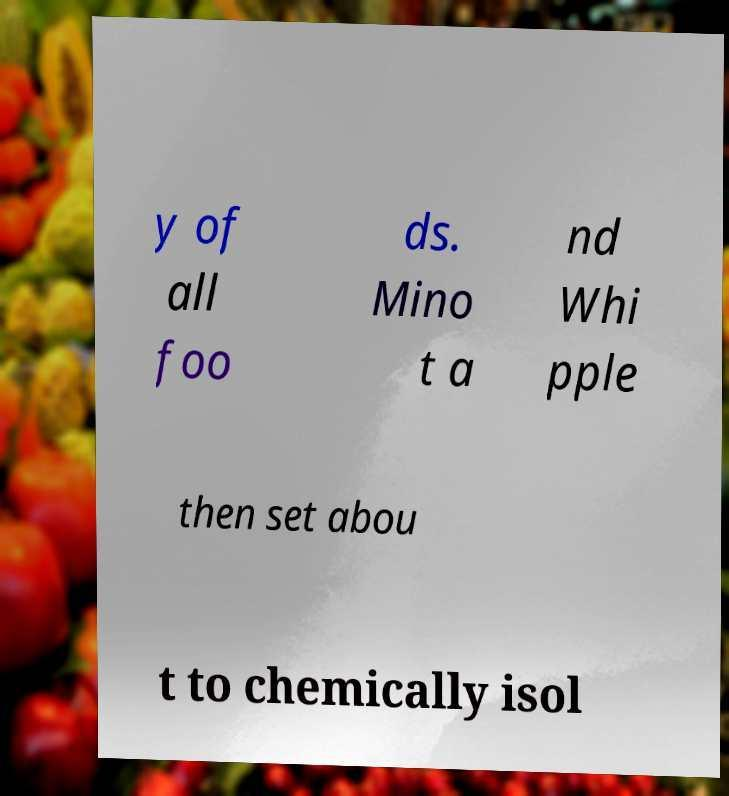For documentation purposes, I need the text within this image transcribed. Could you provide that? y of all foo ds. Mino t a nd Whi pple then set abou t to chemically isol 